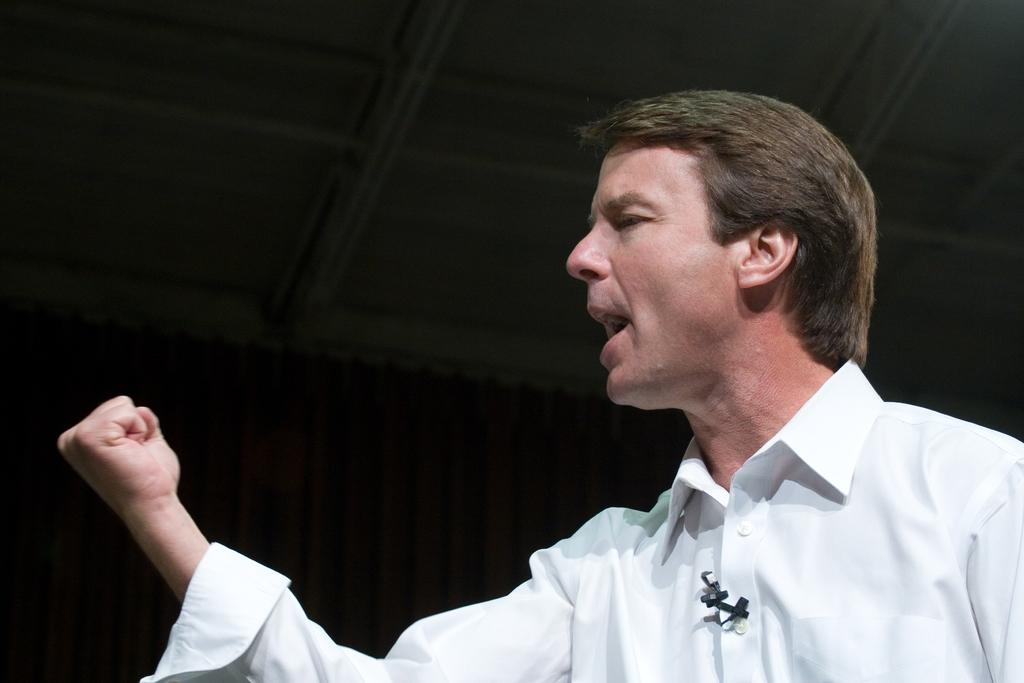What can be seen in the image? There is a person in the image. What is the person wearing? The person is wearing a white dress. What is the person doing with their hand? The person is holding their fist tightly. What can be seen in the background of the image? There is a curtain in the background of the image. What color is the curtain? The curtain is maroon in color. What type of button is the person wearing on their dress in the image? There is no button mentioned on the dress in the image; the person is wearing a white dress. How does the person's stomach look in the image? The provided facts do not mention the person's stomach, so we cannot determine its appearance from the image. 